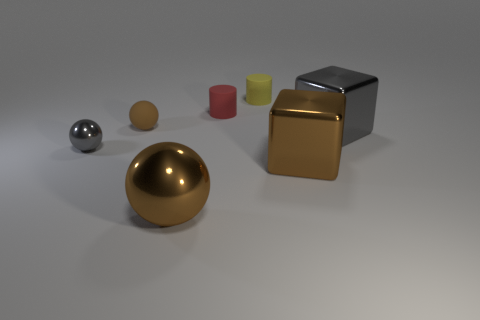Is there a block of the same size as the yellow cylinder?
Make the answer very short. No. What is the material of the brown ball that is the same size as the gray shiny block?
Ensure brevity in your answer.  Metal. There is a object that is both behind the small shiny object and in front of the small brown rubber ball; what is its shape?
Provide a short and direct response. Cube. The tiny thing that is in front of the large gray block is what color?
Offer a terse response. Gray. There is a object that is both to the left of the gray metallic block and right of the yellow thing; what size is it?
Your response must be concise. Large. Is the material of the big gray object the same as the big brown object that is left of the brown block?
Offer a very short reply. Yes. What number of other big metal things have the same shape as the big gray thing?
Offer a terse response. 1. There is a small ball that is the same color as the large metallic sphere; what material is it?
Provide a succinct answer. Rubber. What number of red cylinders are there?
Make the answer very short. 1. There is a small brown matte object; is its shape the same as the gray thing that is left of the large brown sphere?
Keep it short and to the point. Yes. 